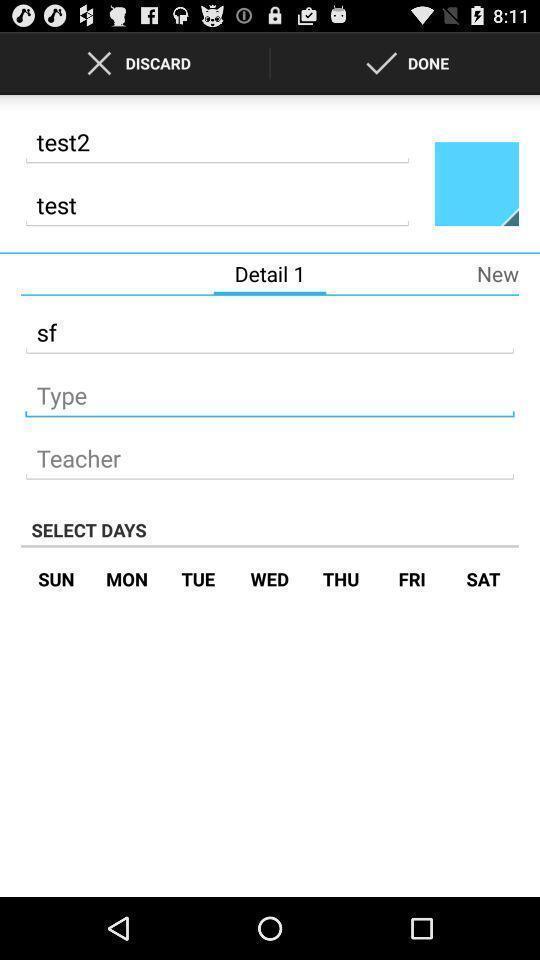Tell me about the visual elements in this screen capture. Screen displaying the page of a study app. 